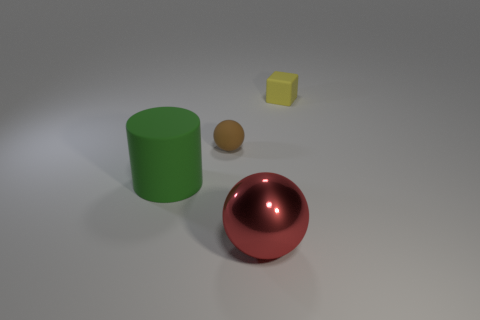What number of objects are to the left of the metal sphere and in front of the brown object?
Provide a succinct answer. 1. Is the shape of the tiny rubber object to the left of the yellow cube the same as  the green thing?
Give a very brief answer. No. There is a red sphere that is the same size as the green rubber cylinder; what material is it?
Your response must be concise. Metal. Are there the same number of large green cylinders that are on the left side of the tiny yellow rubber cube and small objects left of the big green thing?
Your response must be concise. No. There is a small rubber object that is in front of the yellow matte cube that is on the right side of the brown matte thing; what number of green rubber cylinders are in front of it?
Ensure brevity in your answer.  1. There is a large matte cylinder; is it the same color as the tiny rubber object that is left of the yellow matte object?
Make the answer very short. No. What size is the green cylinder that is the same material as the tiny brown sphere?
Provide a short and direct response. Large. There is a small object that is in front of the matte thing that is to the right of the thing that is in front of the cylinder; what is it made of?
Give a very brief answer. Rubber. Is the large red thing made of the same material as the ball behind the big matte cylinder?
Make the answer very short. No. What material is the other tiny object that is the same shape as the red thing?
Offer a very short reply. Rubber. 